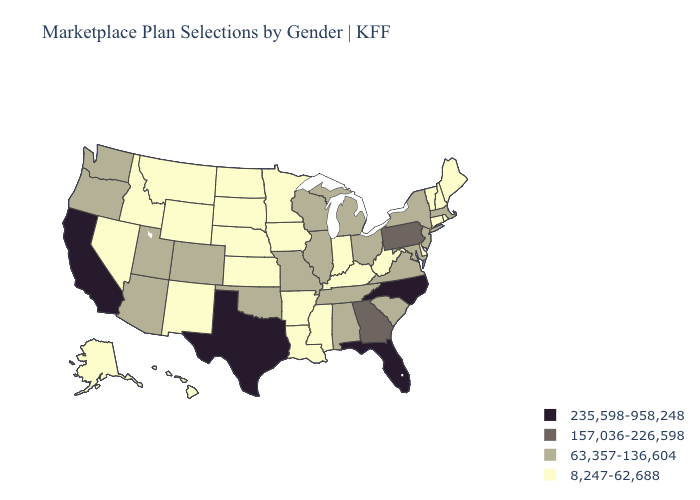What is the value of Montana?
Short answer required. 8,247-62,688. Does Oklahoma have the highest value in the USA?
Keep it brief. No. Name the states that have a value in the range 8,247-62,688?
Answer briefly. Alaska, Arkansas, Connecticut, Delaware, Hawaii, Idaho, Indiana, Iowa, Kansas, Kentucky, Louisiana, Maine, Minnesota, Mississippi, Montana, Nebraska, Nevada, New Hampshire, New Mexico, North Dakota, Rhode Island, South Dakota, Vermont, West Virginia, Wyoming. Does Louisiana have the lowest value in the South?
Answer briefly. Yes. What is the lowest value in states that border Kansas?
Write a very short answer. 8,247-62,688. What is the value of Oklahoma?
Write a very short answer. 63,357-136,604. What is the highest value in the USA?
Quick response, please. 235,598-958,248. What is the highest value in states that border Arizona?
Be succinct. 235,598-958,248. Does South Carolina have the highest value in the USA?
Quick response, please. No. Which states have the lowest value in the USA?
Give a very brief answer. Alaska, Arkansas, Connecticut, Delaware, Hawaii, Idaho, Indiana, Iowa, Kansas, Kentucky, Louisiana, Maine, Minnesota, Mississippi, Montana, Nebraska, Nevada, New Hampshire, New Mexico, North Dakota, Rhode Island, South Dakota, Vermont, West Virginia, Wyoming. What is the value of Arkansas?
Be succinct. 8,247-62,688. What is the value of Pennsylvania?
Answer briefly. 157,036-226,598. Does Idaho have a lower value than Texas?
Write a very short answer. Yes. Name the states that have a value in the range 8,247-62,688?
Answer briefly. Alaska, Arkansas, Connecticut, Delaware, Hawaii, Idaho, Indiana, Iowa, Kansas, Kentucky, Louisiana, Maine, Minnesota, Mississippi, Montana, Nebraska, Nevada, New Hampshire, New Mexico, North Dakota, Rhode Island, South Dakota, Vermont, West Virginia, Wyoming. 